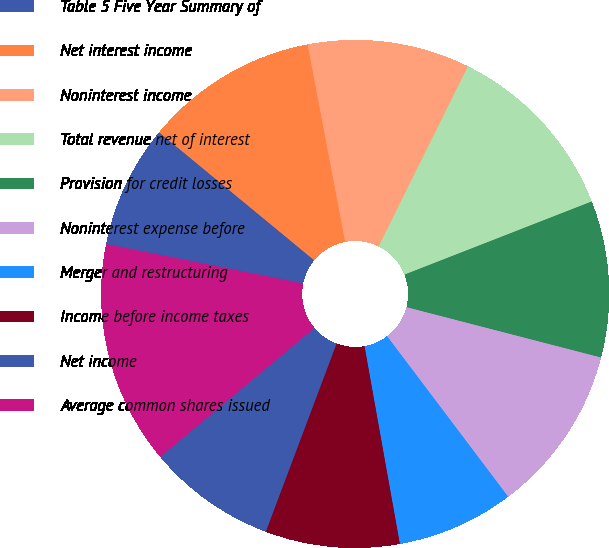<chart> <loc_0><loc_0><loc_500><loc_500><pie_chart><fcel>Table 5 Five Year Summary of<fcel>Net interest income<fcel>Noninterest income<fcel>Total revenue net of interest<fcel>Provision for credit losses<fcel>Noninterest expense before<fcel>Merger and restructuring<fcel>Income before income taxes<fcel>Net income<fcel>Average common shares issued<nl><fcel>7.83%<fcel>11.03%<fcel>10.32%<fcel>11.74%<fcel>9.96%<fcel>10.68%<fcel>7.47%<fcel>8.54%<fcel>8.19%<fcel>14.23%<nl></chart> 